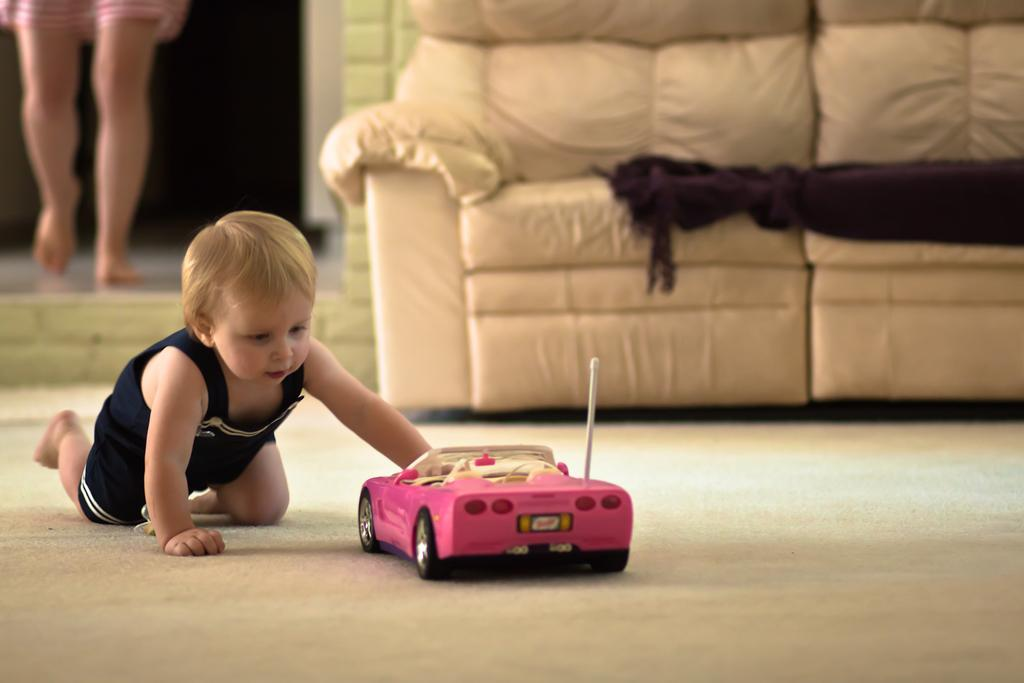What is the kid doing on the left side of the image? The kid is playing with a car toy on the left side of the image. What is located behind the kid? There is a sofa behind the kid. What is on the sofa? A cloth is placed on the sofa. Can you describe the person in the background of the image? There is a person in the background of the image, but no specific details are provided. What type of throne is the kid sitting on in the image? There is no throne present in the image; the kid is playing with a car toy on a sofa. 